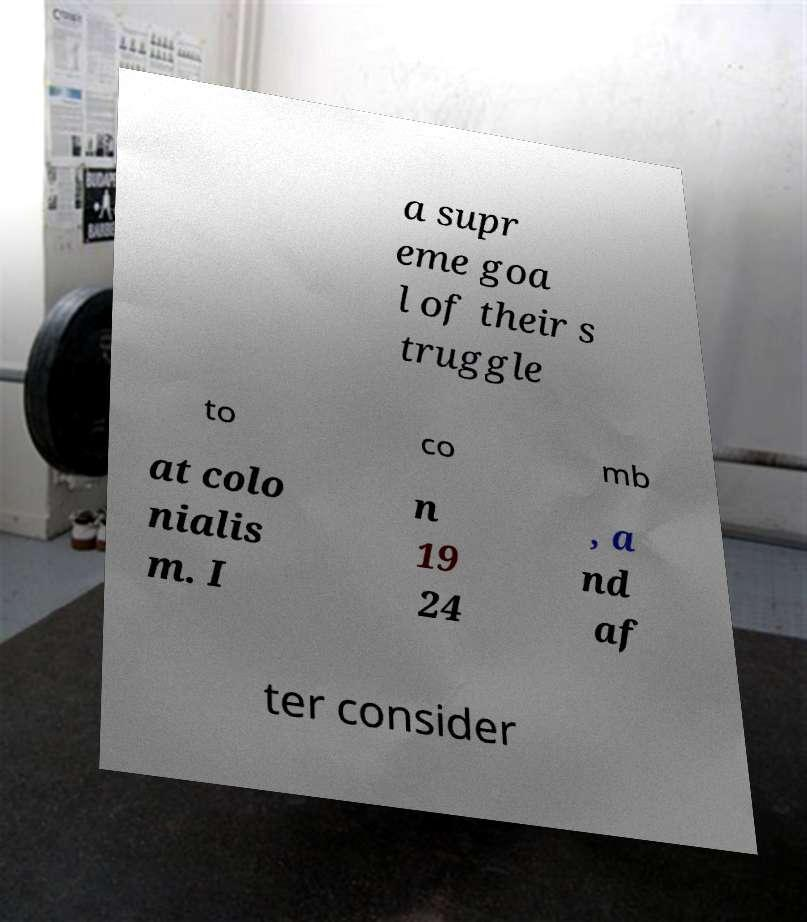Could you assist in decoding the text presented in this image and type it out clearly? a supr eme goa l of their s truggle to co mb at colo nialis m. I n 19 24 , a nd af ter consider 